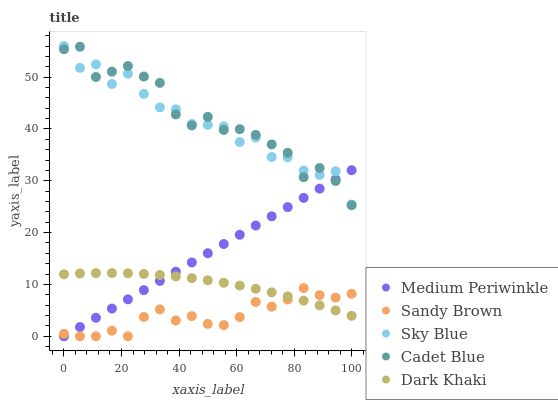Does Sandy Brown have the minimum area under the curve?
Answer yes or no. Yes. Does Cadet Blue have the maximum area under the curve?
Answer yes or no. Yes. Does Cadet Blue have the minimum area under the curve?
Answer yes or no. No. Does Sandy Brown have the maximum area under the curve?
Answer yes or no. No. Is Medium Periwinkle the smoothest?
Answer yes or no. Yes. Is Sky Blue the roughest?
Answer yes or no. Yes. Is Sandy Brown the smoothest?
Answer yes or no. No. Is Sandy Brown the roughest?
Answer yes or no. No. Does Sandy Brown have the lowest value?
Answer yes or no. Yes. Does Cadet Blue have the lowest value?
Answer yes or no. No. Does Sky Blue have the highest value?
Answer yes or no. Yes. Does Cadet Blue have the highest value?
Answer yes or no. No. Is Sandy Brown less than Cadet Blue?
Answer yes or no. Yes. Is Cadet Blue greater than Dark Khaki?
Answer yes or no. Yes. Does Dark Khaki intersect Sandy Brown?
Answer yes or no. Yes. Is Dark Khaki less than Sandy Brown?
Answer yes or no. No. Is Dark Khaki greater than Sandy Brown?
Answer yes or no. No. Does Sandy Brown intersect Cadet Blue?
Answer yes or no. No. 